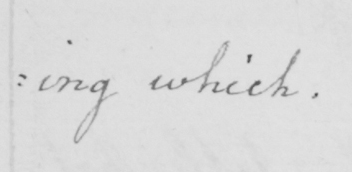What text is written in this handwritten line? : ing which . 